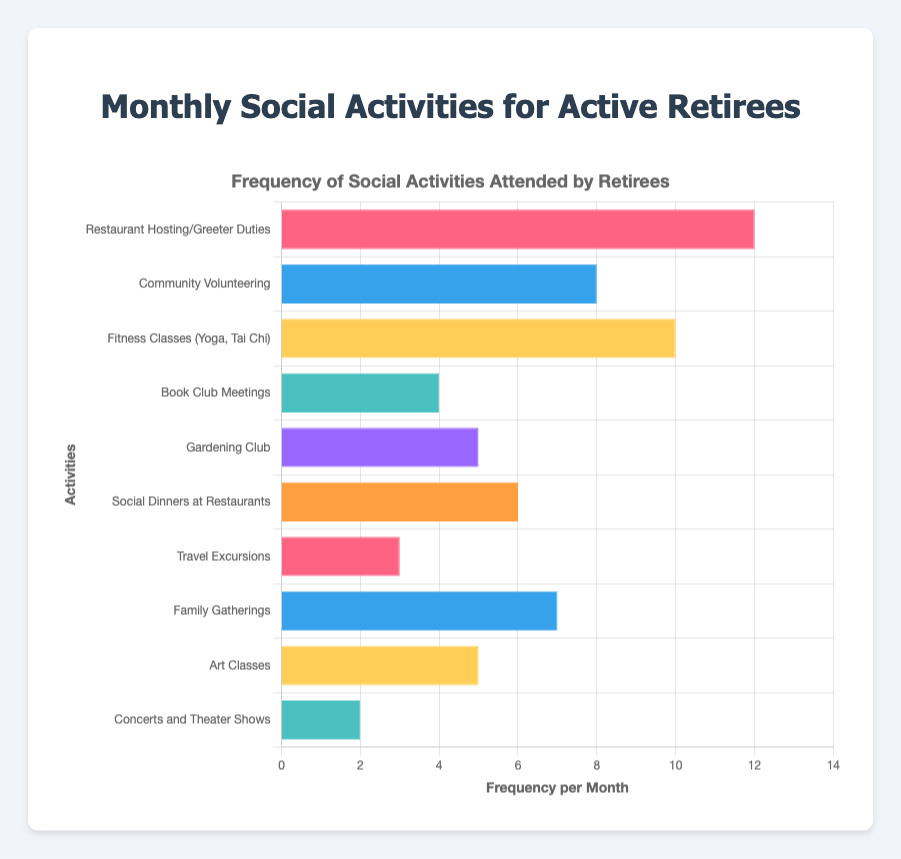Which activity is attended the most frequently per month? The bar representing "Restaurant Hosting/Greeter Duties" is the longest, reaching 12 on the x-axis, indicating it is attended the most frequently.
Answer: Restaurant Hosting/Greeter Duties Which activity is attended the least frequently per month? The bar representing "Concerts and Theater Shows" is the shortest, reaching only 2 on the x-axis, indicating it is attended the least frequently.
Answer: Concerts and Theater Shows What is the total frequency of all social activities attended per month? Sum the frequencies of all activities: 12 + 8 + 10 + 4 + 5 + 6 + 3 + 7 + 5 + 2 = 62.
Answer: 62 How much more frequently are Fitness Classes attended compared to Travel Excursions? Subtract the frequency of Travel Excursions from Fitness Classes: 10 - 3 = 7.
Answer: 7 Which activities have the same frequency of attendance per month? The bars for "Gardening Club" and "Art Classes" are the same length, both reaching 5 on the x-axis.
Answer: Gardening Club and Art Classes What is the average frequency of Community Volunteering and Family Gatherings? Sum the frequencies of Community Volunteering and Family Gatherings and then divide by 2: (8 + 7) / 2 = 7.5.
Answer: 7.5 How does the frequency of Social Dinners at Restaurants compare to Book Club Meetings? The bar for Social Dinners at Restaurants (6) is longer than the bar for Book Club Meetings (4).
Answer: Social Dinners at Restaurants have a higher frequency Is the frequency of Art Classes more or less than the frequency of Gardening Club? The bars for Art Classes and Gardening Club are the same length, both reaching 5 on the x-axis.
Answer: Equal What is the combined frequency of Restaurant Hosting/Greeter Duties and Fitness Classes? Add the frequencies of Restaurant Hosting/Greeter Duties and Fitness Classes: 12 + 10 = 22.
Answer: 22 Which activity among Travel Excursions, Book Club Meetings, and Concerts and Theater Shows is attended the most often? The bar for Book Club Meetings (4) is the longest among the three, so it is attended the most.
Answer: Book Club Meetings 